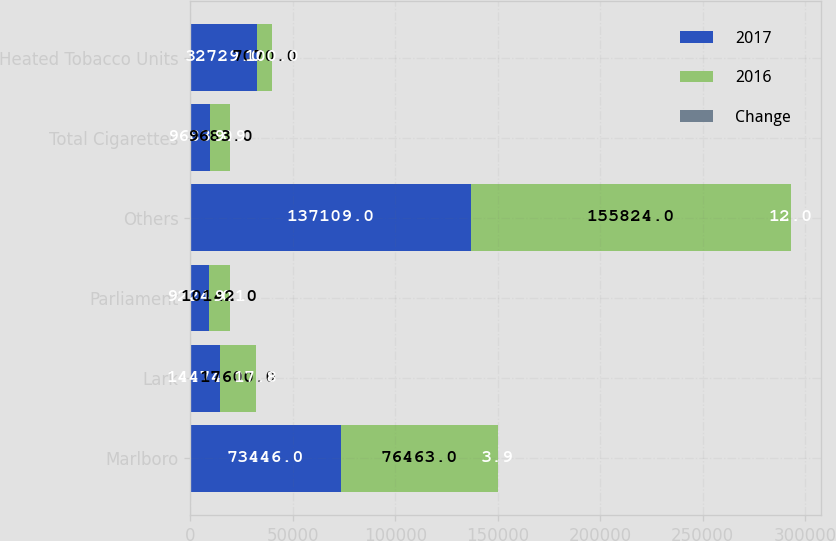<chart> <loc_0><loc_0><loc_500><loc_500><stacked_bar_chart><ecel><fcel>Marlboro<fcel>Lark<fcel>Parliament<fcel>Others<fcel>Total Cigarettes<fcel>Heated Tobacco Units<nl><fcel>2017<fcel>73446<fcel>14474<fcel>9224<fcel>137109<fcel>9683<fcel>32729<nl><fcel>2016<fcel>76463<fcel>17600<fcel>10142<fcel>155824<fcel>9683<fcel>7070<nl><fcel>Change<fcel>3.9<fcel>17.8<fcel>9.1<fcel>12<fcel>9.9<fcel>100<nl></chart> 